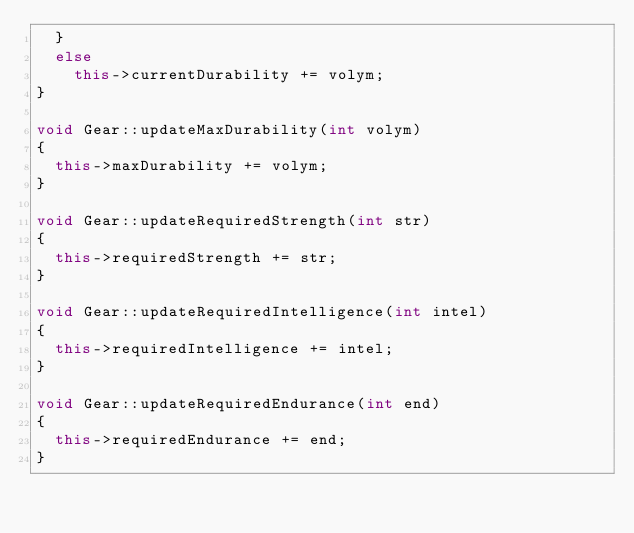Convert code to text. <code><loc_0><loc_0><loc_500><loc_500><_C++_>	}
	else
		this->currentDurability += volym;
}

void Gear::updateMaxDurability(int volym)
{
	this->maxDurability += volym;
}

void Gear::updateRequiredStrength(int str)
{
	this->requiredStrength += str;
}

void Gear::updateRequiredIntelligence(int intel)
{
	this->requiredIntelligence += intel;
}

void Gear::updateRequiredEndurance(int end)
{
	this->requiredEndurance += end;
}
</code> 